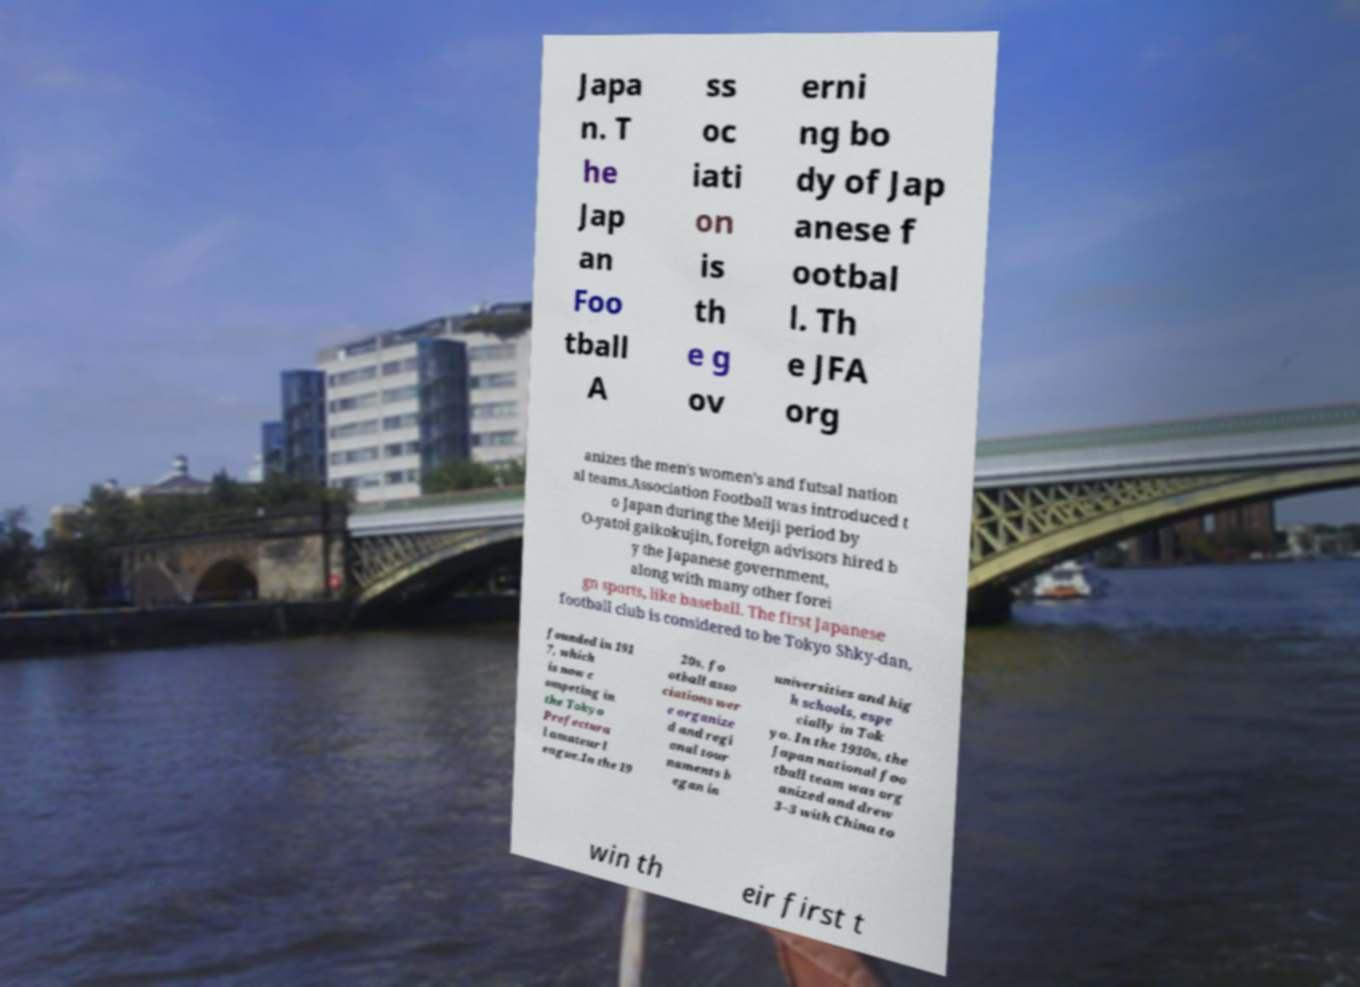Could you assist in decoding the text presented in this image and type it out clearly? Japa n. T he Jap an Foo tball A ss oc iati on is th e g ov erni ng bo dy of Jap anese f ootbal l. Th e JFA org anizes the men's women's and futsal nation al teams.Association Football was introduced t o Japan during the Meiji period by O-yatoi gaikokujin, foreign advisors hired b y the Japanese government, along with many other forei gn sports, like baseball. The first Japanese football club is considered to be Tokyo Shky-dan, founded in 191 7, which is now c ompeting in the Tokyo Prefectura l amateur l eague.In the 19 20s, fo otball asso ciations wer e organize d and regi onal tour naments b egan in universities and hig h schools, espe cially in Tok yo. In the 1930s, the Japan national foo tball team was org anized and drew 3–3 with China to win th eir first t 